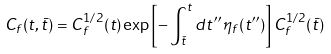<formula> <loc_0><loc_0><loc_500><loc_500>C _ { f } ( t , \bar { t } ) = C _ { f } ^ { 1 / 2 } ( t ) \exp \left [ - \int _ { \bar { t } } ^ { t } d t ^ { \prime \prime } \, \eta _ { f } ( t ^ { \prime \prime } ) \right ] C _ { f } ^ { 1 / 2 } ( \bar { t } )</formula> 